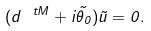Convert formula to latex. <formula><loc_0><loc_0><loc_500><loc_500>( d ^ { \ t M } + i { \tilde { \theta } _ { 0 } } ) { \tilde { u } } = 0 .</formula> 